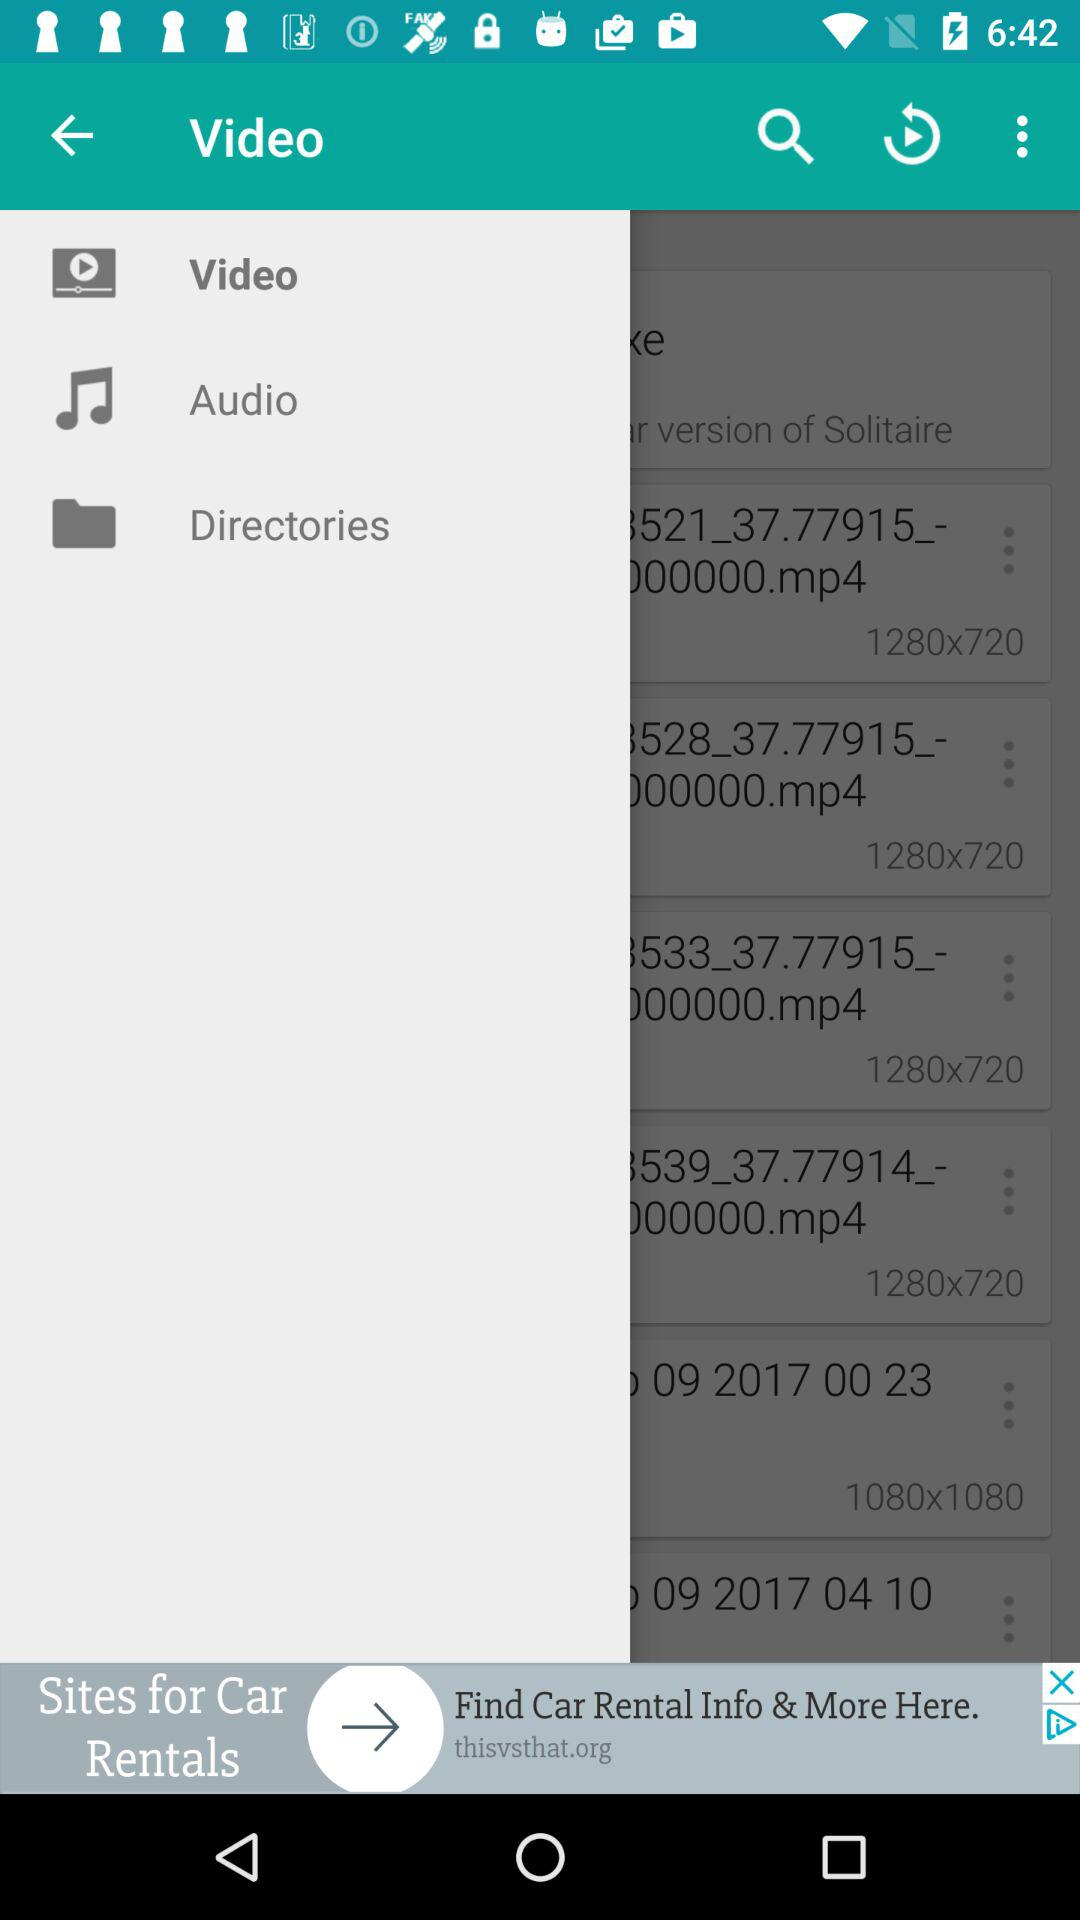What are the resolutions of videos? The resolutions are 1280x720 and 1080x1080. 